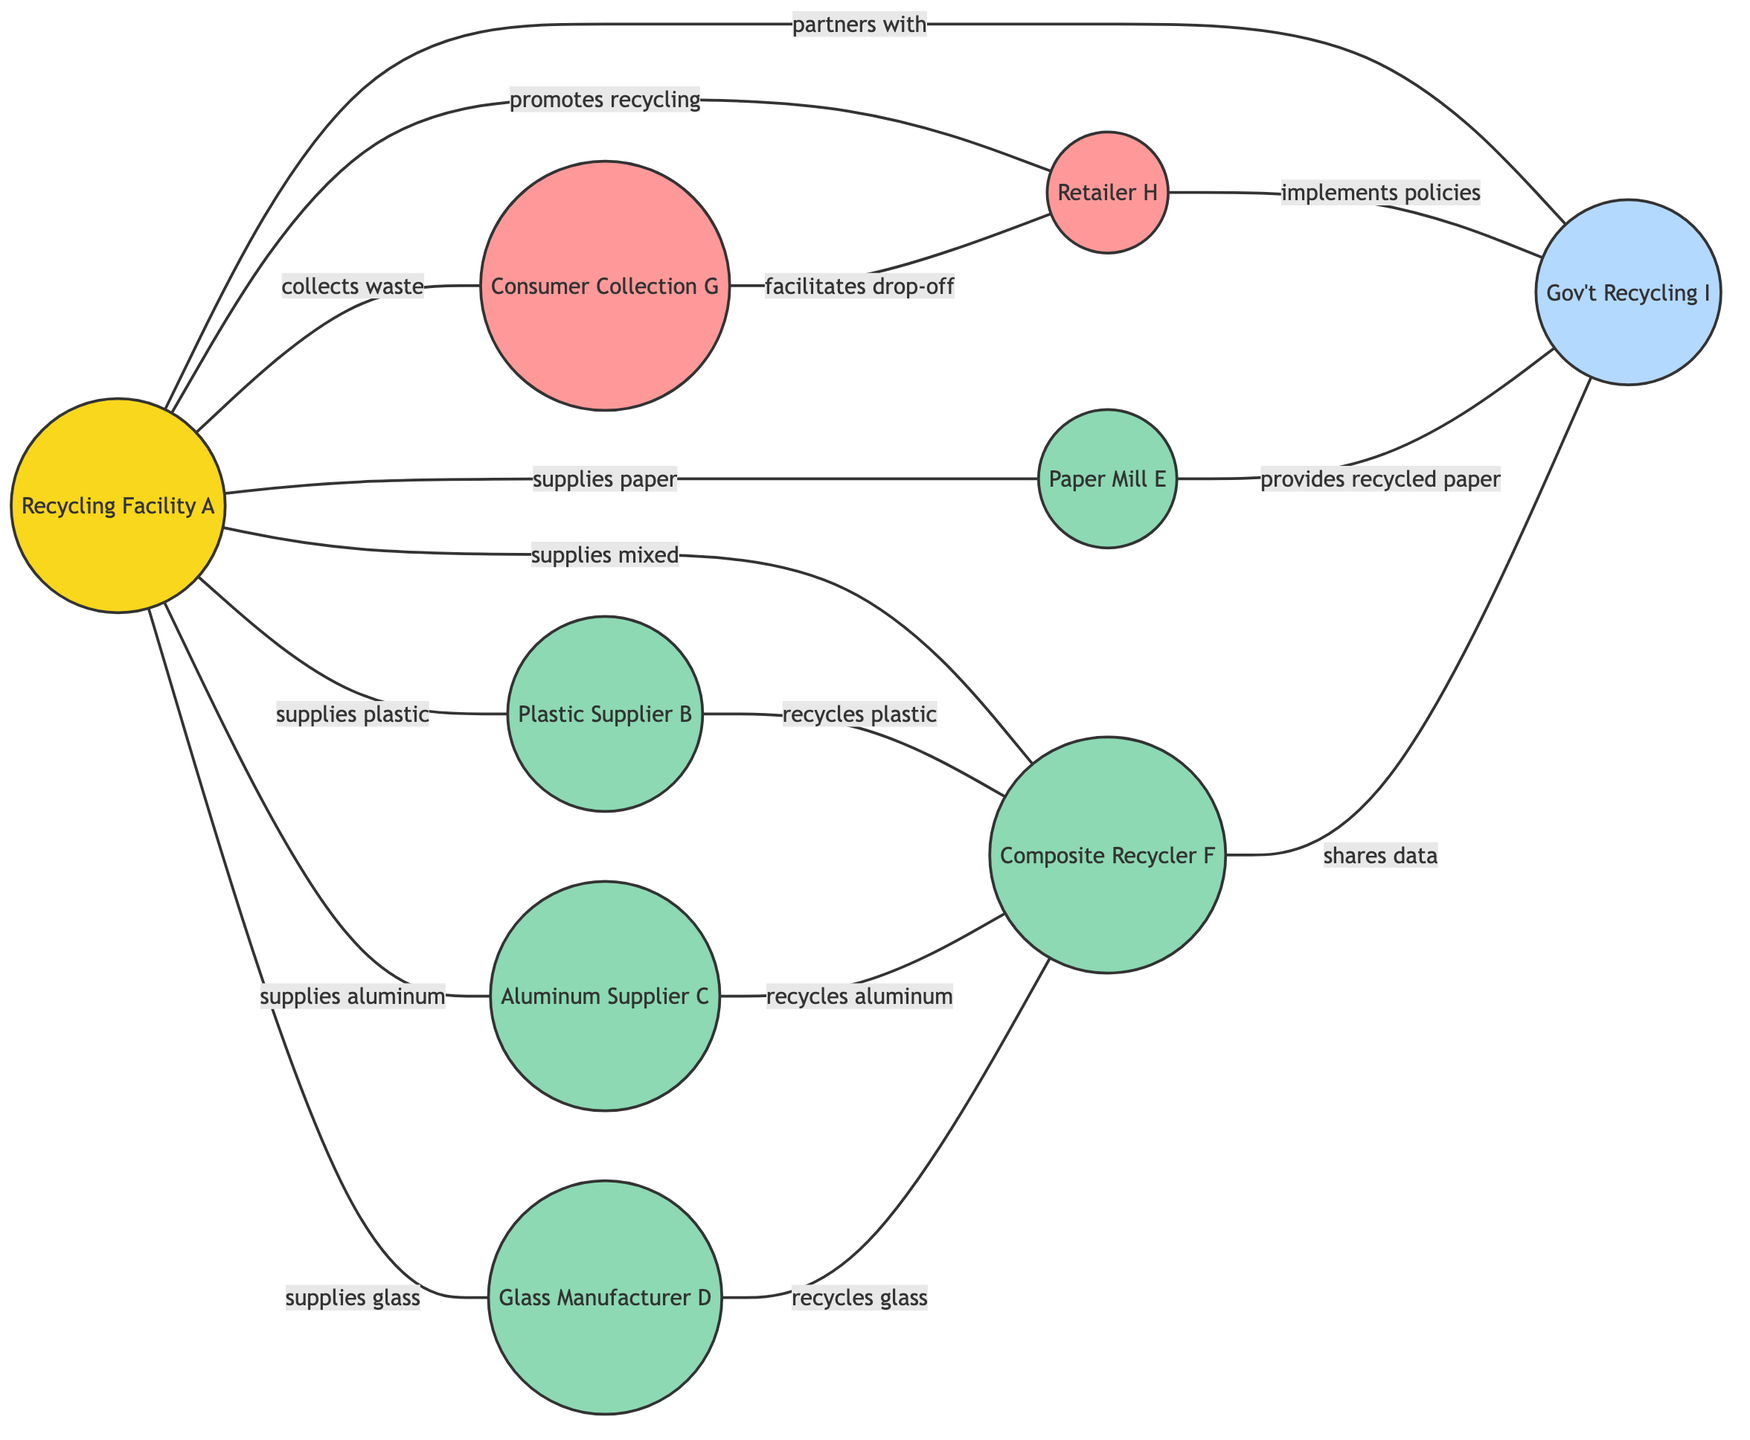What is the total number of nodes in the diagram? The diagram contains a specific set of nodes that represent various entities. Counting each node in the provided data, there are 9 nodes listed.
Answer: 9 Which supplier is connected to the recycling facility A providing paper waste? By examining the edges, the connection showing "supplies paper waste" is between Recycling Facility A and Paper Mill E.
Answer: Paper Mill E How many different types of suppliers are connected to Recycling Facility A? Analyzing the edges connected to Recycling Facility A, there are 5 suppliers: Plastic Supplier B, Aluminum Supplier C, Glass Manufacturer D, Paper Mill E, and Composite Recycler F.
Answer: 5 Which consumer point collects waste from Recycling Facility A? The diagram shows that Consumer Collection Point G is connected to Recycling Facility A with the label "collects consumer waste."
Answer: Consumer Collection Point G What relationship exists between Retailer H and Local Government Recycling Program I? The edge between Retailer H and Local Government Recycling Program I shows that Retailer H "implements recycling policies" for the government program, indicating a supportive correlation in their operations.
Answer: implements recycling policies Who partners with the Recycling Facility A? The edge labeled "partners with" connects Recycling Facility A to Local Government Recycling Program I, indicating that they collaborate.
Answer: Local Government Recycling Program I Which supplier is involved in recycling mixed waste? The Composite Recycler F shows a connection with Recycling Facility A that provides mixed waste, highlighting its recycling role.
Answer: Composite Recycler F How many edges connect Recycling Facility A to its suppliers? By counting the edges that connect from Recycling Facility A to its suppliers, there are 5 distinct connections, each representing a specific type of waste supplied.
Answer: 5 Which entity facilitates the drop-off for consumers? The diagram indicates that the edge between Consumer Collection Point G and Retailer H shows a role in facilitating drop-off, which is important for consumer engagement.
Answer: Retailer H 